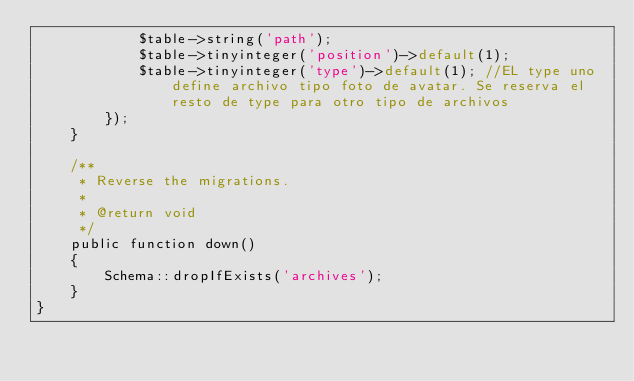Convert code to text. <code><loc_0><loc_0><loc_500><loc_500><_PHP_>            $table->string('path');
            $table->tinyinteger('position')->default(1);
            $table->tinyinteger('type')->default(1); //EL type uno define archivo tipo foto de avatar. Se reserva el resto de type para otro tipo de archivos
        });
    }

    /**
     * Reverse the migrations.
     *
     * @return void
     */
    public function down()
    {
        Schema::dropIfExists('archives');
    }
}
</code> 